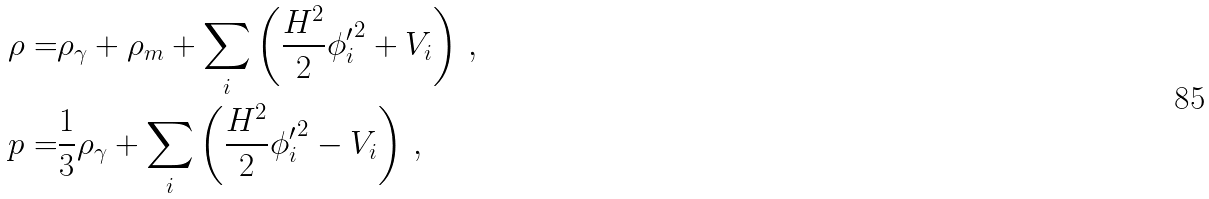<formula> <loc_0><loc_0><loc_500><loc_500>\rho = & \rho _ { \gamma } + \rho _ { m } + \sum _ { i } \left ( \frac { H ^ { 2 } } { 2 } { \phi _ { i } ^ { \prime } } ^ { 2 } + V _ { i } \right ) \, , \\ p = & \frac { 1 } { 3 } \rho _ { \gamma } + \sum _ { i } \left ( \frac { H ^ { 2 } } { 2 } { \phi _ { i } ^ { \prime } } ^ { 2 } - V _ { i } \right ) \, ,</formula> 